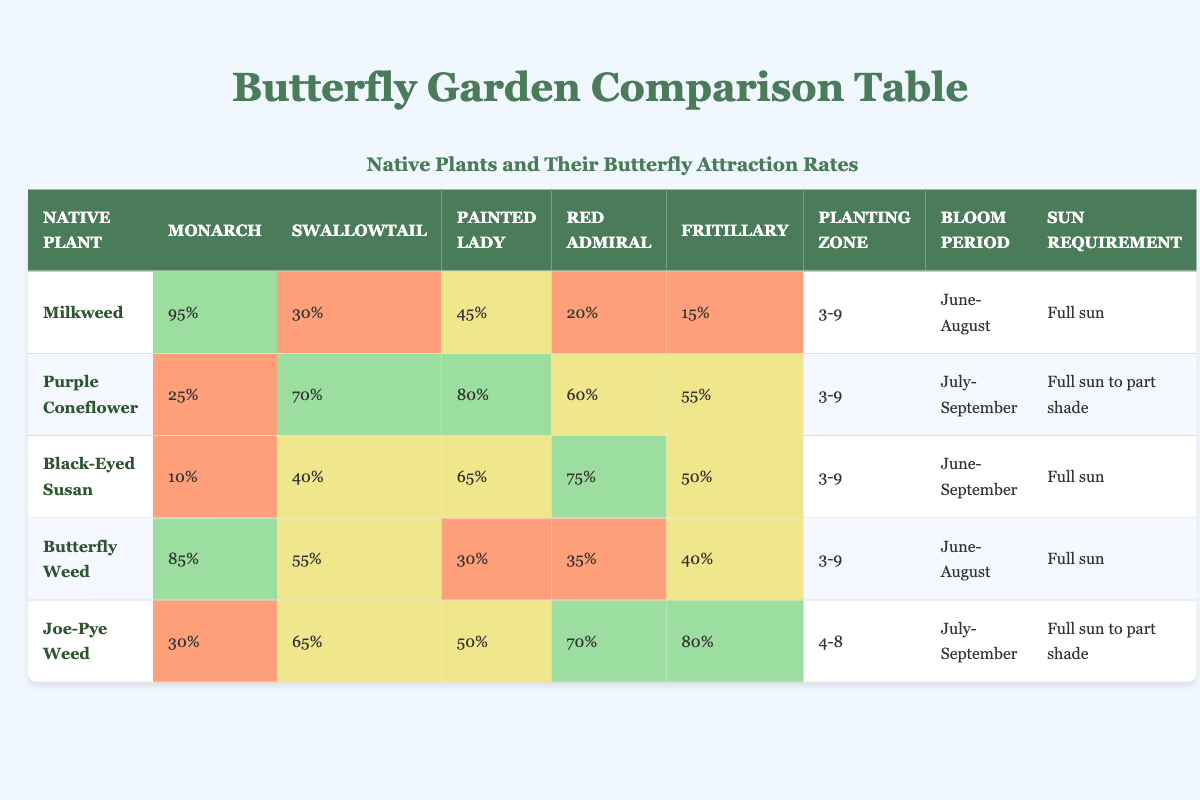What butterfly species is most attracted to Milkweed? The table indicates that Milkweed has a 95% attraction rate for Monarch butterflies, which is the highest percentage listed for any plant in the table.
Answer: Monarch Which plant attracts the highest percentage of Painted Lady butterflies? According to the table, Purple Coneflower has the highest attraction rate for Painted Lady butterflies at 80%.
Answer: Purple Coneflower Is it true that Joe-Pye Weed has a higher attraction rate for Fritillary butterflies than Butterfly Weed? The table shows that Joe-Pye Weed has an 80% attraction rate for Fritillary, while Butterfly Weed has a 40% attraction rate. Therefore, it is true that Joe-Pye Weed has a higher attraction rate for Fritillary butterflies.
Answer: Yes What is the average attraction rate for Red Admiral butterflies across all plants? To find the average, add up the attraction rates: (20 + 60 + 75 + 35 + 70) = 260. Then divide by the number of plants, which is 5: 260/5 = 52. Therefore, the average attraction rate for Red Admiral butterflies is 52%.
Answer: 52% Which native plant attracts the least number of Swallowtail butterflies? By looking at the table, Black-Eyed Susan shows a 40% attraction rate for Swallowtail butterflies, which is the lowest compared to all other plants listed.
Answer: Black-Eyed Susan What is the total attraction rate for Monarch butterflies derived from all the plants? The total attraction rate for Monarch butterflies can be calculated by adding their individual rates: 95 + 25 + 10 + 85 + 30 = 245. Therefore, the total attraction rate for Monarch butterflies is 245%.
Answer: 245% Which two plants have similar attraction rates for Fritillary butterflies? Analyzing the table, Butterfly Weed has a 40% attraction rate for Fritillary butterflies, while Black-Eyed Susan has 50%. While they are not identical, they are relatively close. Thus, the two plants that are nearest in attraction rate are Butterfly Weed and Black-Eyed Susan.
Answer: Butterfly Weed and Black-Eyed Susan Which butterfly species is least attracted to Black-Eyed Susan? The table indicates that Black-Eyed Susan has the lowest attraction rate for Monarch butterflies at only 10%.
Answer: Monarch Which plant is best suited for planting in USDA zone 4? The table shows that Joe-Pye Weed is the only plant listed with a planting zone that includes zone 4 (specifically, 4-8). Therefore, Joe-Pye Weed is the best suited for this planting zone.
Answer: Joe-Pye Weed 